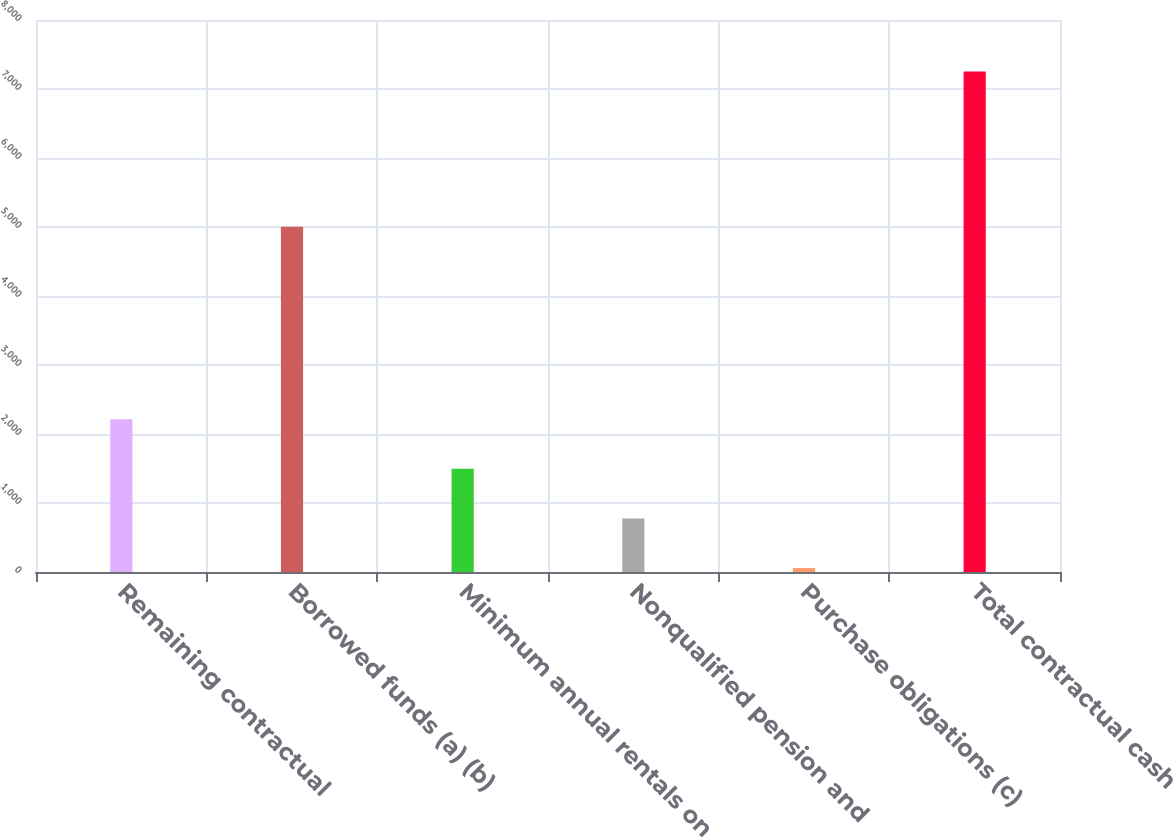<chart> <loc_0><loc_0><loc_500><loc_500><bar_chart><fcel>Remaining contractual<fcel>Borrowed funds (a) (b)<fcel>Minimum annual rentals on<fcel>Nonqualified pension and<fcel>Purchase obligations (c)<fcel>Total contractual cash<nl><fcel>2214.8<fcel>5005<fcel>1495.2<fcel>775.6<fcel>56<fcel>7252<nl></chart> 